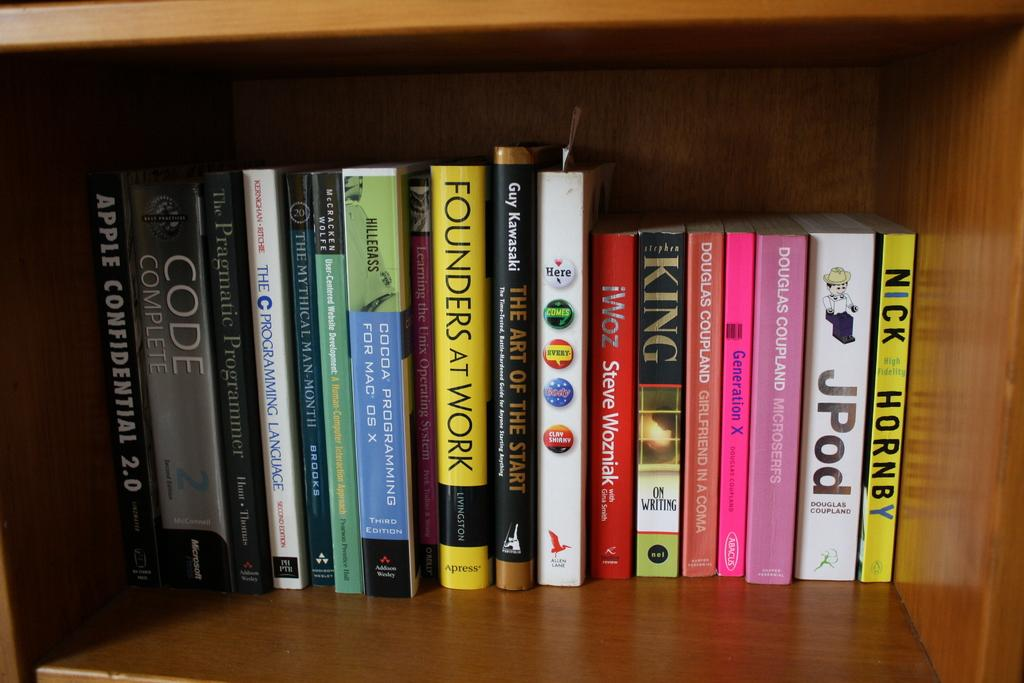<image>
Offer a succinct explanation of the picture presented. The full bookshelf has book titles such as On Writing and Generation X on it. 